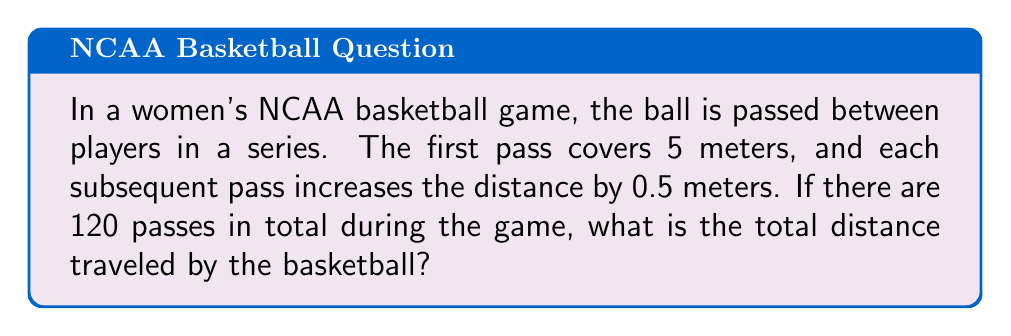Can you solve this math problem? Let's approach this step-by-step using the arithmetic sequence formula:

1) We have an arithmetic sequence where:
   $a_1 = 5$ (first term)
   $d = 0.5$ (common difference)
   $n = 120$ (number of terms)

2) The last term of the sequence can be calculated using:
   $a_n = a_1 + (n-1)d$
   $a_{120} = 5 + (120-1)(0.5) = 5 + 59.5 = 64.5$

3) To find the sum of this arithmetic sequence, we use the formula:
   $S_n = \frac{n}{2}(a_1 + a_n)$

4) Substituting our values:
   $S_{120} = \frac{120}{2}(5 + 64.5)$

5) Simplifying:
   $S_{120} = 60(69.5) = 4170$

Therefore, the total distance traveled by the basketball is 4170 meters.
Answer: 4170 meters 